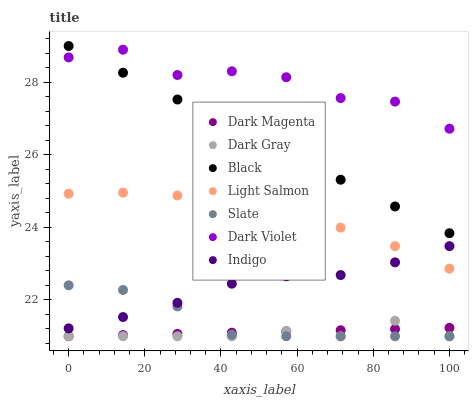Does Dark Gray have the minimum area under the curve?
Answer yes or no. Yes. Does Dark Violet have the maximum area under the curve?
Answer yes or no. Yes. Does Indigo have the minimum area under the curve?
Answer yes or no. No. Does Indigo have the maximum area under the curve?
Answer yes or no. No. Is Dark Magenta the smoothest?
Answer yes or no. Yes. Is Dark Violet the roughest?
Answer yes or no. Yes. Is Indigo the smoothest?
Answer yes or no. No. Is Indigo the roughest?
Answer yes or no. No. Does Dark Magenta have the lowest value?
Answer yes or no. Yes. Does Indigo have the lowest value?
Answer yes or no. No. Does Black have the highest value?
Answer yes or no. Yes. Does Indigo have the highest value?
Answer yes or no. No. Is Dark Gray less than Dark Violet?
Answer yes or no. Yes. Is Black greater than Indigo?
Answer yes or no. Yes. Does Dark Gray intersect Slate?
Answer yes or no. Yes. Is Dark Gray less than Slate?
Answer yes or no. No. Is Dark Gray greater than Slate?
Answer yes or no. No. Does Dark Gray intersect Dark Violet?
Answer yes or no. No. 